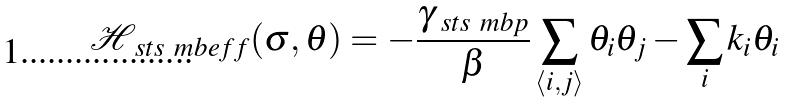Convert formula to latex. <formula><loc_0><loc_0><loc_500><loc_500>\mathcal { H } _ { \ s t s \ m b { e f f } } ( \sigma , \theta ) = - \frac { \gamma _ { \ s t s \ m b { p } } } { \beta } \sum _ { \left < i , j \right > } \theta _ { i } \theta _ { j } - \sum _ { i } k _ { i } \theta _ { i }</formula> 